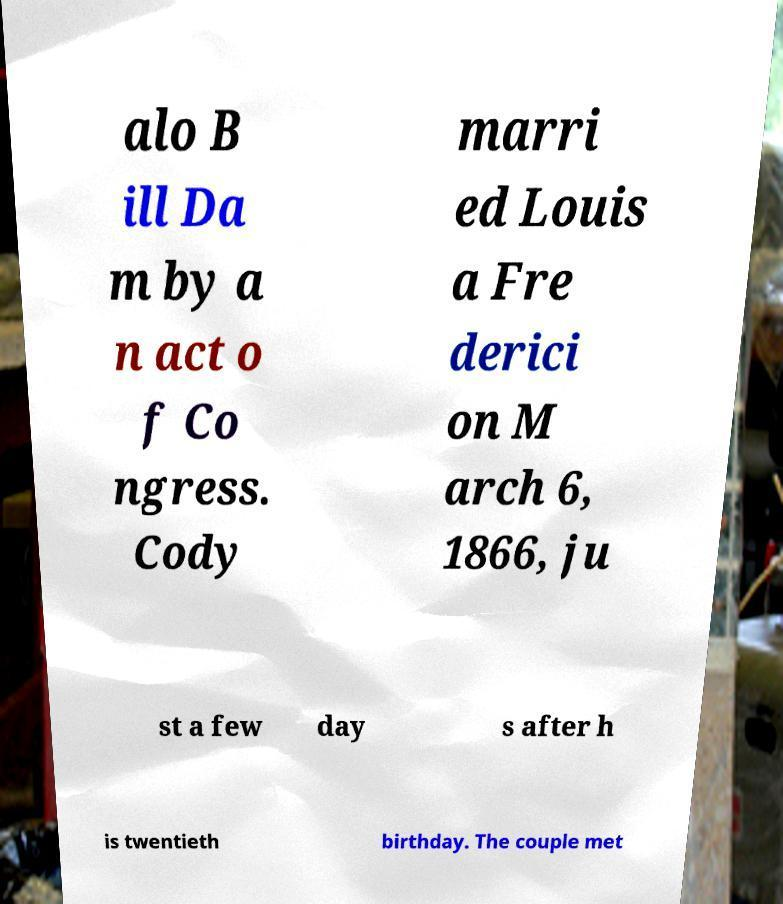Could you assist in decoding the text presented in this image and type it out clearly? alo B ill Da m by a n act o f Co ngress. Cody marri ed Louis a Fre derici on M arch 6, 1866, ju st a few day s after h is twentieth birthday. The couple met 